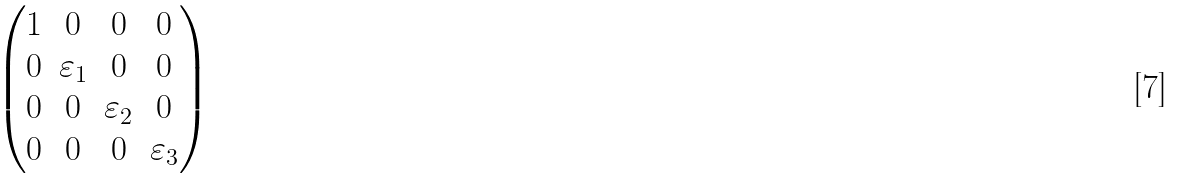Convert formula to latex. <formula><loc_0><loc_0><loc_500><loc_500>\begin{pmatrix} 1 & 0 & 0 & 0 \\ 0 & \varepsilon _ { 1 } & 0 & 0 \\ 0 & 0 & \varepsilon _ { 2 } & 0 \\ 0 & 0 & 0 & \varepsilon _ { 3 } \end{pmatrix}</formula> 